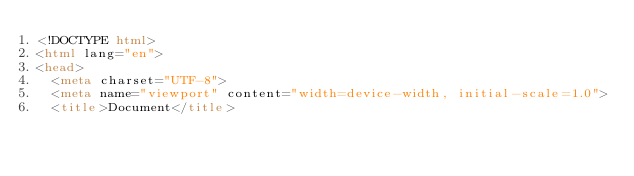Convert code to text. <code><loc_0><loc_0><loc_500><loc_500><_HTML_><!DOCTYPE html>
<html lang="en">
<head>
  <meta charset="UTF-8">
  <meta name="viewport" content="width=device-width, initial-scale=1.0">
  <title>Document</title></code> 